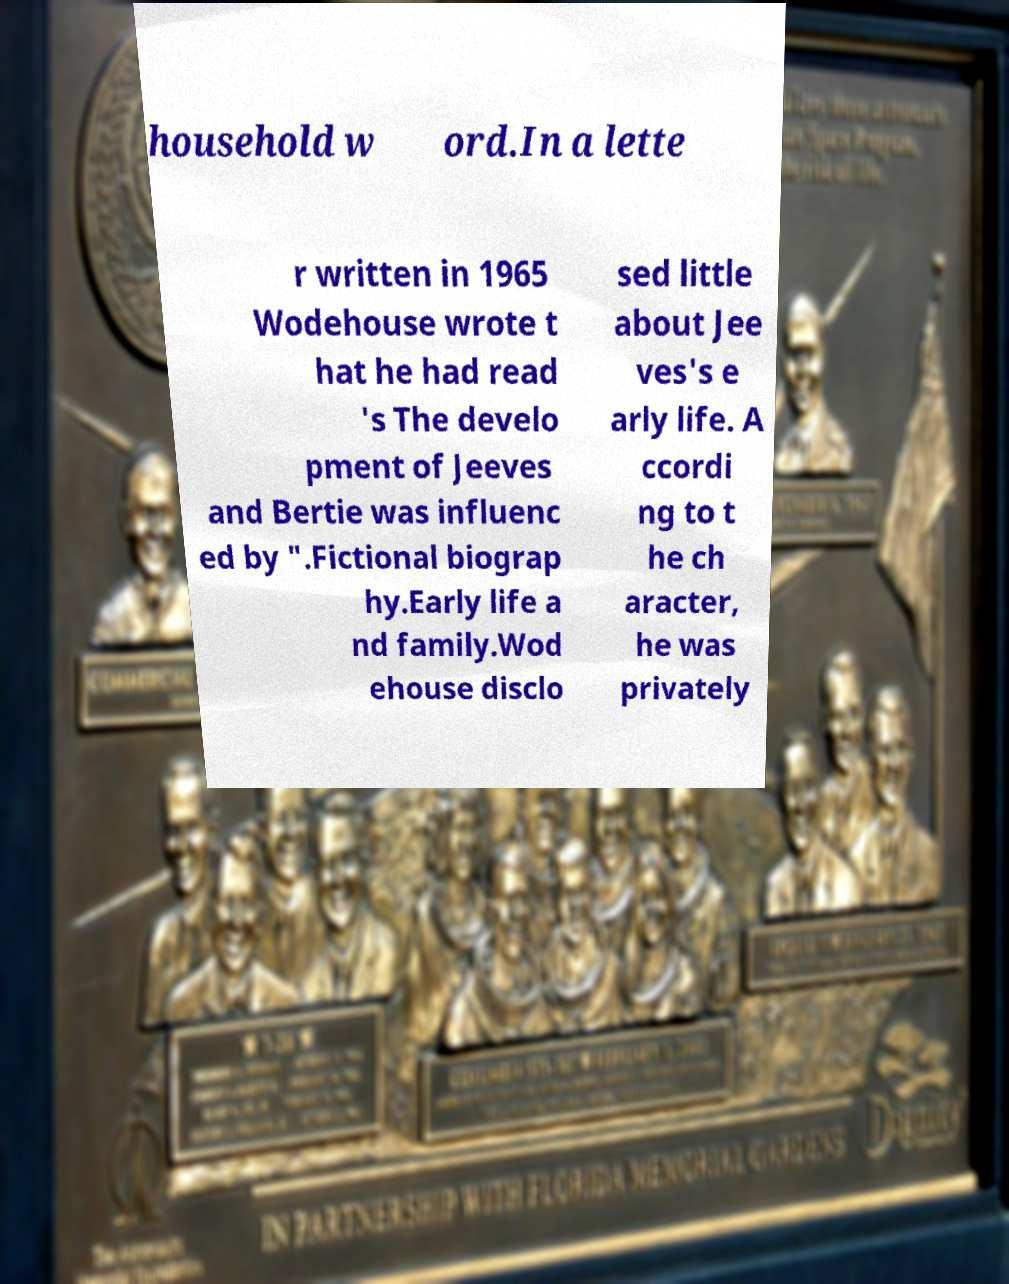I need the written content from this picture converted into text. Can you do that? household w ord.In a lette r written in 1965 Wodehouse wrote t hat he had read 's The develo pment of Jeeves and Bertie was influenc ed by ".Fictional biograp hy.Early life a nd family.Wod ehouse disclo sed little about Jee ves's e arly life. A ccordi ng to t he ch aracter, he was privately 